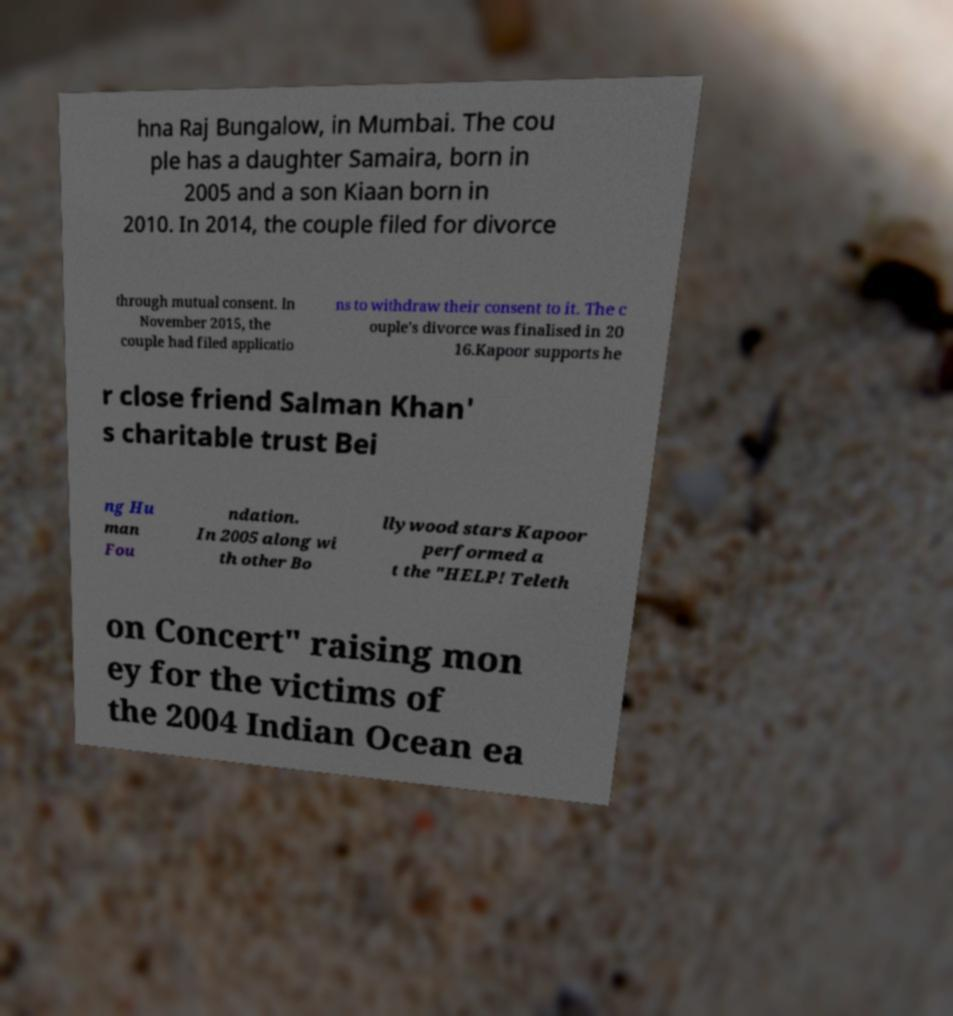Could you assist in decoding the text presented in this image and type it out clearly? hna Raj Bungalow, in Mumbai. The cou ple has a daughter Samaira, born in 2005 and a son Kiaan born in 2010. In 2014, the couple filed for divorce through mutual consent. In November 2015, the couple had filed applicatio ns to withdraw their consent to it. The c ouple's divorce was finalised in 20 16.Kapoor supports he r close friend Salman Khan' s charitable trust Bei ng Hu man Fou ndation. In 2005 along wi th other Bo llywood stars Kapoor performed a t the "HELP! Teleth on Concert" raising mon ey for the victims of the 2004 Indian Ocean ea 